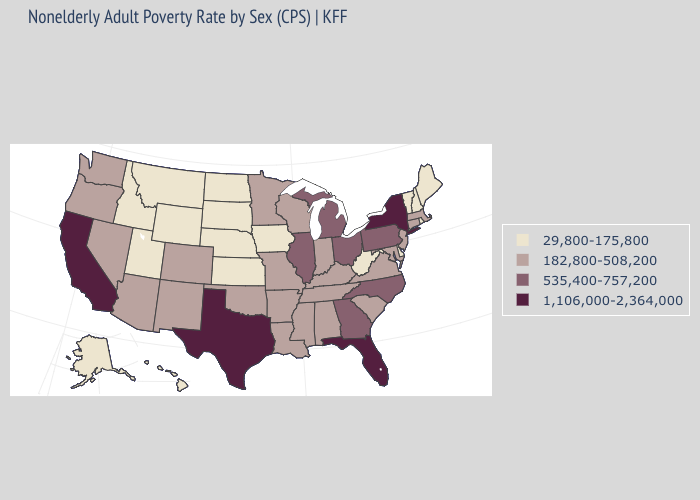What is the value of Washington?
Keep it brief. 182,800-508,200. Name the states that have a value in the range 535,400-757,200?
Give a very brief answer. Georgia, Illinois, Michigan, North Carolina, Ohio, Pennsylvania. What is the value of Indiana?
Write a very short answer. 182,800-508,200. Which states have the highest value in the USA?
Write a very short answer. California, Florida, New York, Texas. Name the states that have a value in the range 1,106,000-2,364,000?
Keep it brief. California, Florida, New York, Texas. What is the highest value in the USA?
Answer briefly. 1,106,000-2,364,000. What is the highest value in the West ?
Quick response, please. 1,106,000-2,364,000. Name the states that have a value in the range 1,106,000-2,364,000?
Quick response, please. California, Florida, New York, Texas. Which states have the highest value in the USA?
Write a very short answer. California, Florida, New York, Texas. What is the value of Massachusetts?
Write a very short answer. 182,800-508,200. What is the value of Hawaii?
Be succinct. 29,800-175,800. Name the states that have a value in the range 29,800-175,800?
Answer briefly. Alaska, Delaware, Hawaii, Idaho, Iowa, Kansas, Maine, Montana, Nebraska, New Hampshire, North Dakota, Rhode Island, South Dakota, Utah, Vermont, West Virginia, Wyoming. What is the value of Iowa?
Quick response, please. 29,800-175,800. What is the value of West Virginia?
Give a very brief answer. 29,800-175,800. Which states have the lowest value in the USA?
Short answer required. Alaska, Delaware, Hawaii, Idaho, Iowa, Kansas, Maine, Montana, Nebraska, New Hampshire, North Dakota, Rhode Island, South Dakota, Utah, Vermont, West Virginia, Wyoming. 